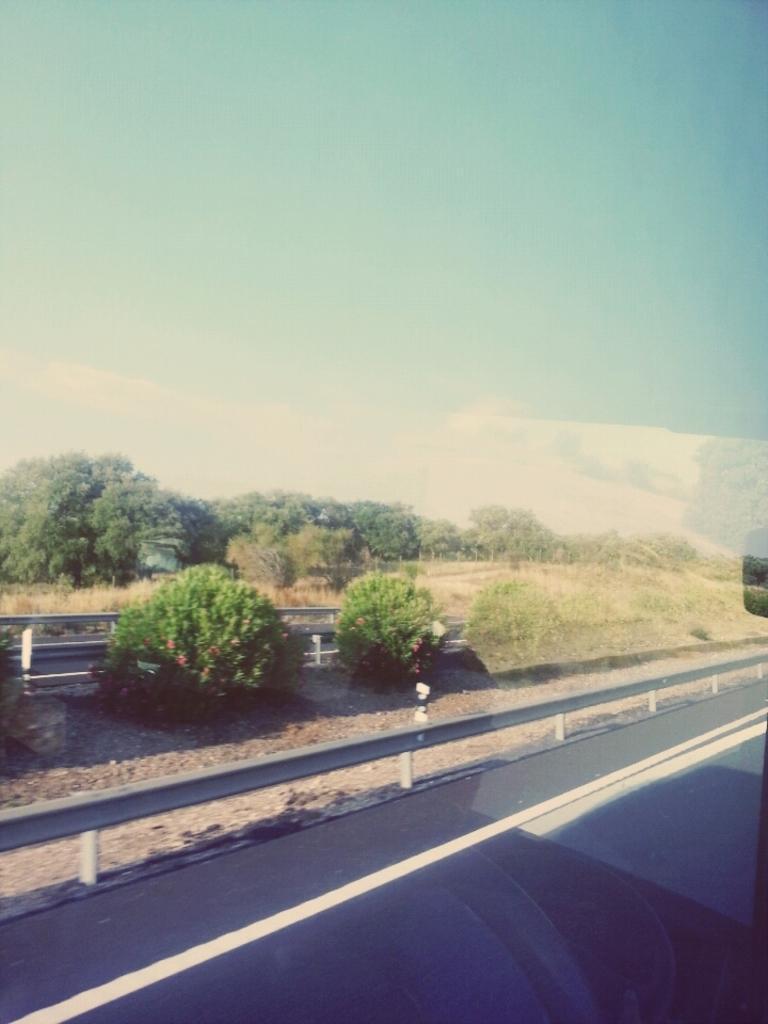Can you describe this image briefly? As we can see in the image there are trees, grass, fence and on the top there is sky. 